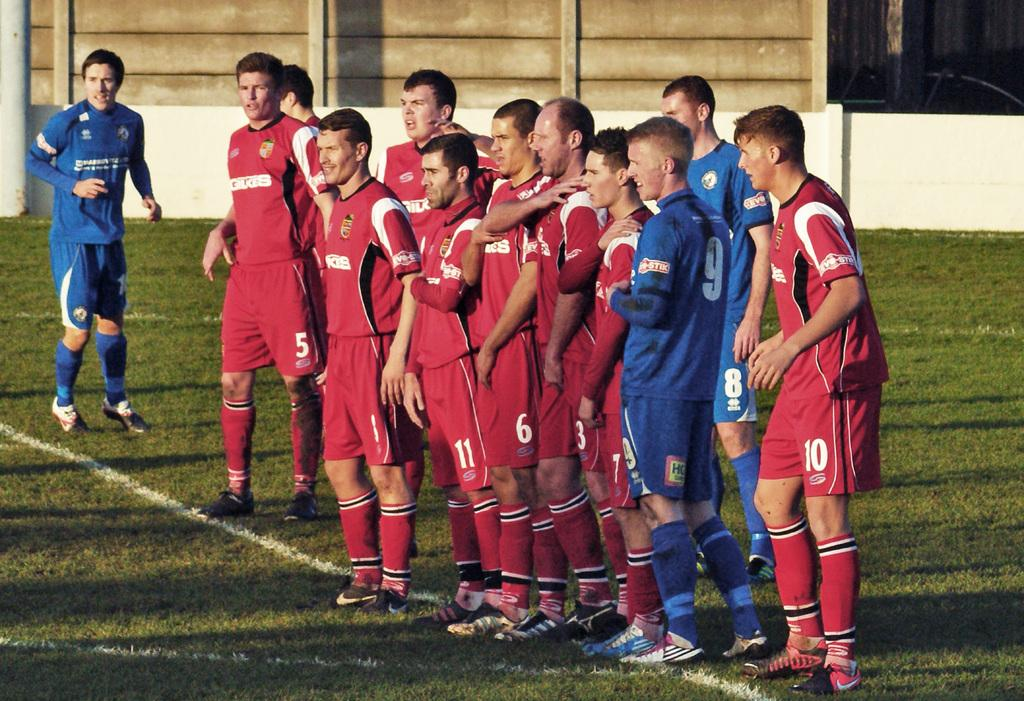How many people are in the image? There is a group of people in the image, but the exact number is not specified. What are the people doing in the image? The people are standing on the ground. What can be seen in the background of the image? There is a wall in the background of the image. What type of bait is being used by the people in the image? There is no indication of any fishing or bait-related activity in the image. Can you describe the flower arrangement on the wall in the image? There is no mention of a flower arrangement or any decorative elements on the wall in the image. 